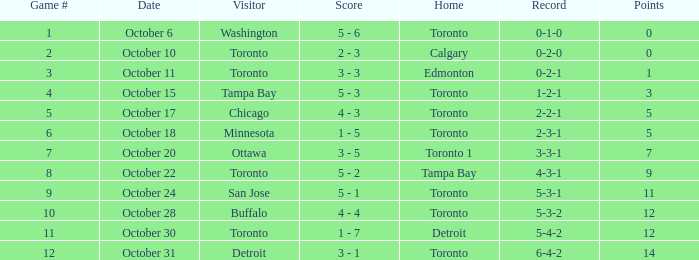What is the score when the record was 5-4-2? 1 - 7. 